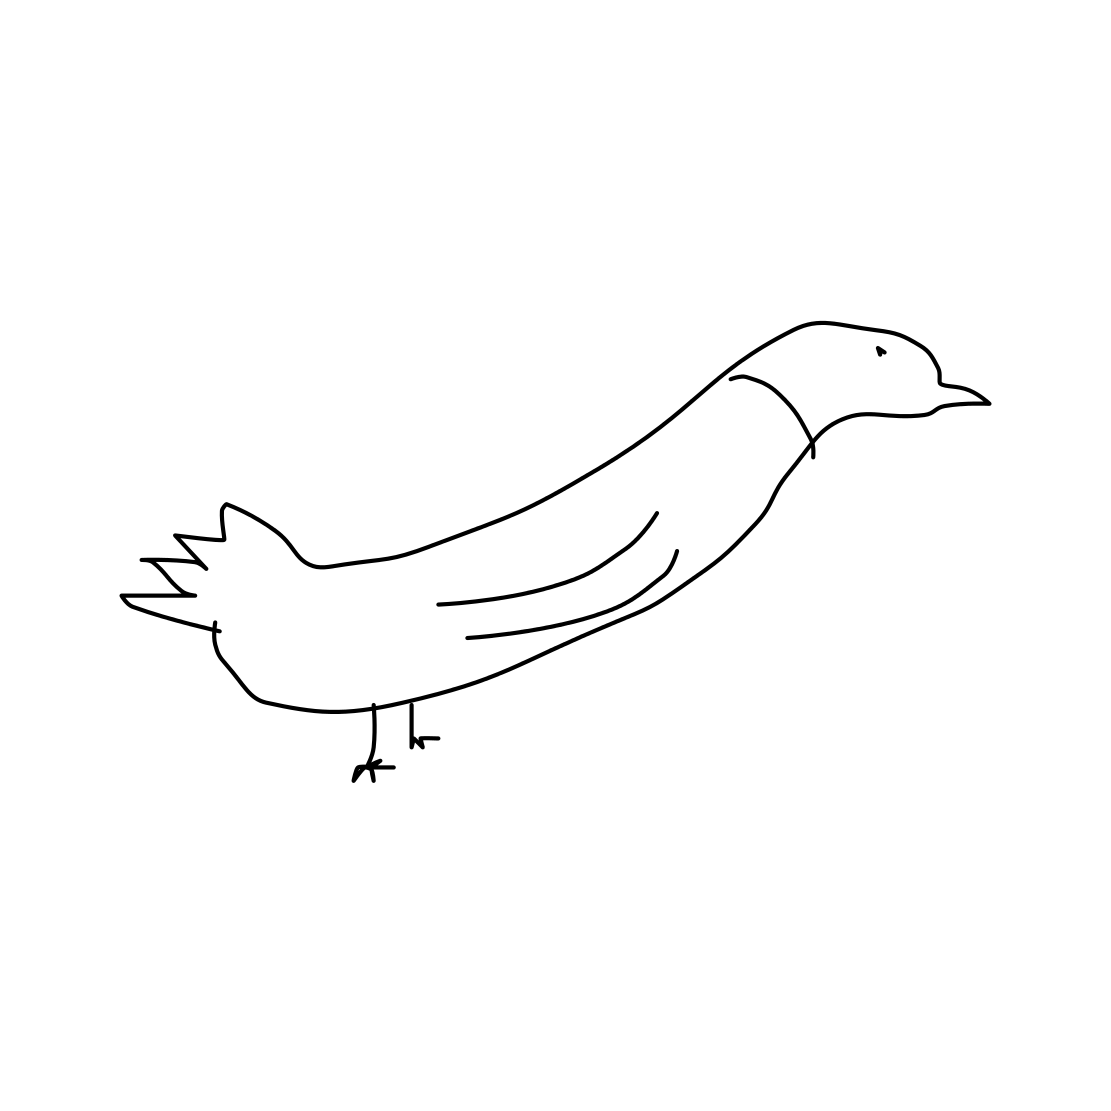Could this drawing be suitable for any educational purposes? Certainly, this uncomplicated and clear drawing could be used to help young children recognize the basic form and features of a bird, such as the beak, wings, and legs. 